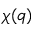Convert formula to latex. <formula><loc_0><loc_0><loc_500><loc_500>\chi ( q )</formula> 